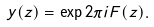<formula> <loc_0><loc_0><loc_500><loc_500>y ( z ) = \exp 2 \pi i F ( z ) .</formula> 